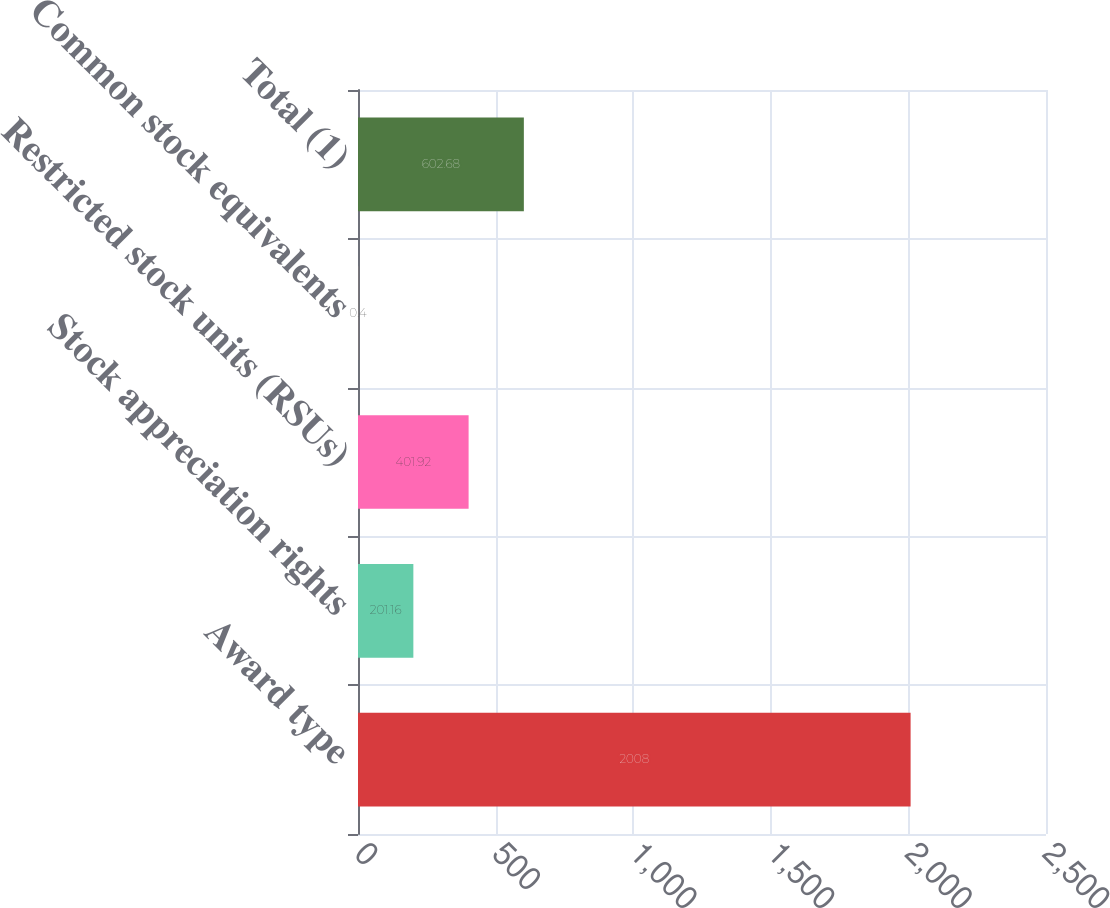<chart> <loc_0><loc_0><loc_500><loc_500><bar_chart><fcel>Award type<fcel>Stock appreciation rights<fcel>Restricted stock units (RSUs)<fcel>Common stock equivalents<fcel>Total (1)<nl><fcel>2008<fcel>201.16<fcel>401.92<fcel>0.4<fcel>602.68<nl></chart> 